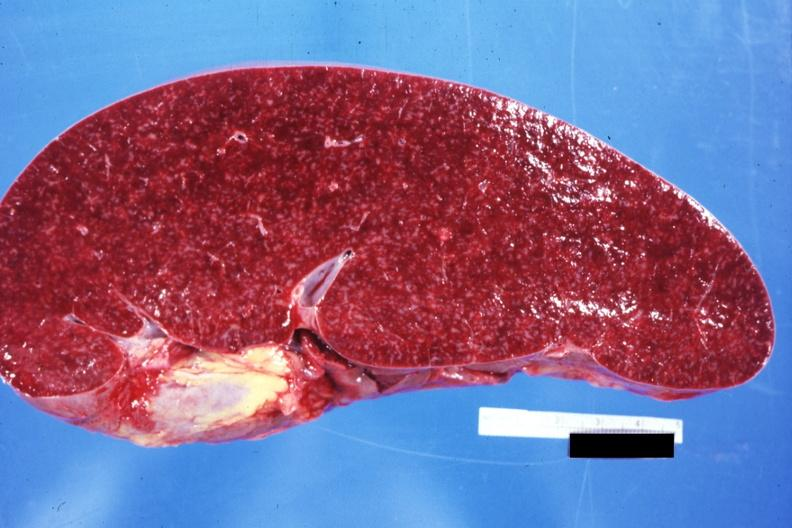what appears normal see other sides this case?
Answer the question using a single word or phrase. Size 